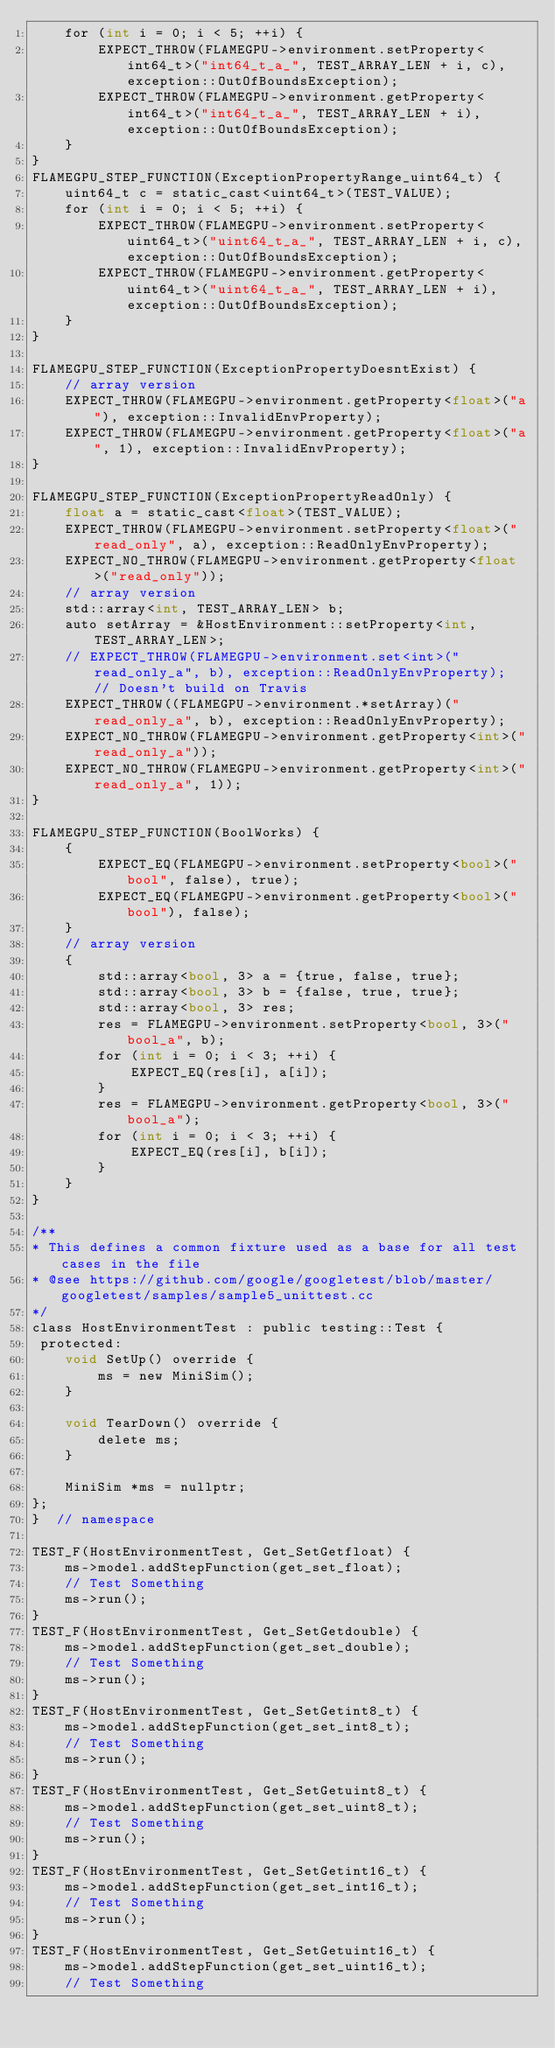Convert code to text. <code><loc_0><loc_0><loc_500><loc_500><_Cuda_>    for (int i = 0; i < 5; ++i) {
        EXPECT_THROW(FLAMEGPU->environment.setProperty<int64_t>("int64_t_a_", TEST_ARRAY_LEN + i, c), exception::OutOfBoundsException);
        EXPECT_THROW(FLAMEGPU->environment.getProperty<int64_t>("int64_t_a_", TEST_ARRAY_LEN + i), exception::OutOfBoundsException);
    }
}
FLAMEGPU_STEP_FUNCTION(ExceptionPropertyRange_uint64_t) {
    uint64_t c = static_cast<uint64_t>(TEST_VALUE);
    for (int i = 0; i < 5; ++i) {
        EXPECT_THROW(FLAMEGPU->environment.setProperty<uint64_t>("uint64_t_a_", TEST_ARRAY_LEN + i, c), exception::OutOfBoundsException);
        EXPECT_THROW(FLAMEGPU->environment.getProperty<uint64_t>("uint64_t_a_", TEST_ARRAY_LEN + i), exception::OutOfBoundsException);
    }
}

FLAMEGPU_STEP_FUNCTION(ExceptionPropertyDoesntExist) {
    // array version
    EXPECT_THROW(FLAMEGPU->environment.getProperty<float>("a"), exception::InvalidEnvProperty);
    EXPECT_THROW(FLAMEGPU->environment.getProperty<float>("a", 1), exception::InvalidEnvProperty);
}

FLAMEGPU_STEP_FUNCTION(ExceptionPropertyReadOnly) {
    float a = static_cast<float>(TEST_VALUE);
    EXPECT_THROW(FLAMEGPU->environment.setProperty<float>("read_only", a), exception::ReadOnlyEnvProperty);
    EXPECT_NO_THROW(FLAMEGPU->environment.getProperty<float>("read_only"));
    // array version
    std::array<int, TEST_ARRAY_LEN> b;
    auto setArray = &HostEnvironment::setProperty<int, TEST_ARRAY_LEN>;
    // EXPECT_THROW(FLAMEGPU->environment.set<int>("read_only_a", b), exception::ReadOnlyEnvProperty);  // Doesn't build on Travis
    EXPECT_THROW((FLAMEGPU->environment.*setArray)("read_only_a", b), exception::ReadOnlyEnvProperty);
    EXPECT_NO_THROW(FLAMEGPU->environment.getProperty<int>("read_only_a"));
    EXPECT_NO_THROW(FLAMEGPU->environment.getProperty<int>("read_only_a", 1));
}

FLAMEGPU_STEP_FUNCTION(BoolWorks) {
    {
        EXPECT_EQ(FLAMEGPU->environment.setProperty<bool>("bool", false), true);
        EXPECT_EQ(FLAMEGPU->environment.getProperty<bool>("bool"), false);
    }
    // array version
    {
        std::array<bool, 3> a = {true, false, true};
        std::array<bool, 3> b = {false, true, true};
        std::array<bool, 3> res;
        res = FLAMEGPU->environment.setProperty<bool, 3>("bool_a", b);
        for (int i = 0; i < 3; ++i) {
            EXPECT_EQ(res[i], a[i]);
        }
        res = FLAMEGPU->environment.getProperty<bool, 3>("bool_a");
        for (int i = 0; i < 3; ++i) {
            EXPECT_EQ(res[i], b[i]);
        }
    }
}

/**
* This defines a common fixture used as a base for all test cases in the file
* @see https://github.com/google/googletest/blob/master/googletest/samples/sample5_unittest.cc
*/
class HostEnvironmentTest : public testing::Test {
 protected:
    void SetUp() override {
        ms = new MiniSim();
    }

    void TearDown() override {
        delete ms;
    }

    MiniSim *ms = nullptr;
};
}  // namespace

TEST_F(HostEnvironmentTest, Get_SetGetfloat) {
    ms->model.addStepFunction(get_set_float);
    // Test Something
    ms->run();
}
TEST_F(HostEnvironmentTest, Get_SetGetdouble) {
    ms->model.addStepFunction(get_set_double);
    // Test Something
    ms->run();
}
TEST_F(HostEnvironmentTest, Get_SetGetint8_t) {
    ms->model.addStepFunction(get_set_int8_t);
    // Test Something
    ms->run();
}
TEST_F(HostEnvironmentTest, Get_SetGetuint8_t) {
    ms->model.addStepFunction(get_set_uint8_t);
    // Test Something
    ms->run();
}
TEST_F(HostEnvironmentTest, Get_SetGetint16_t) {
    ms->model.addStepFunction(get_set_int16_t);
    // Test Something
    ms->run();
}
TEST_F(HostEnvironmentTest, Get_SetGetuint16_t) {
    ms->model.addStepFunction(get_set_uint16_t);
    // Test Something</code> 